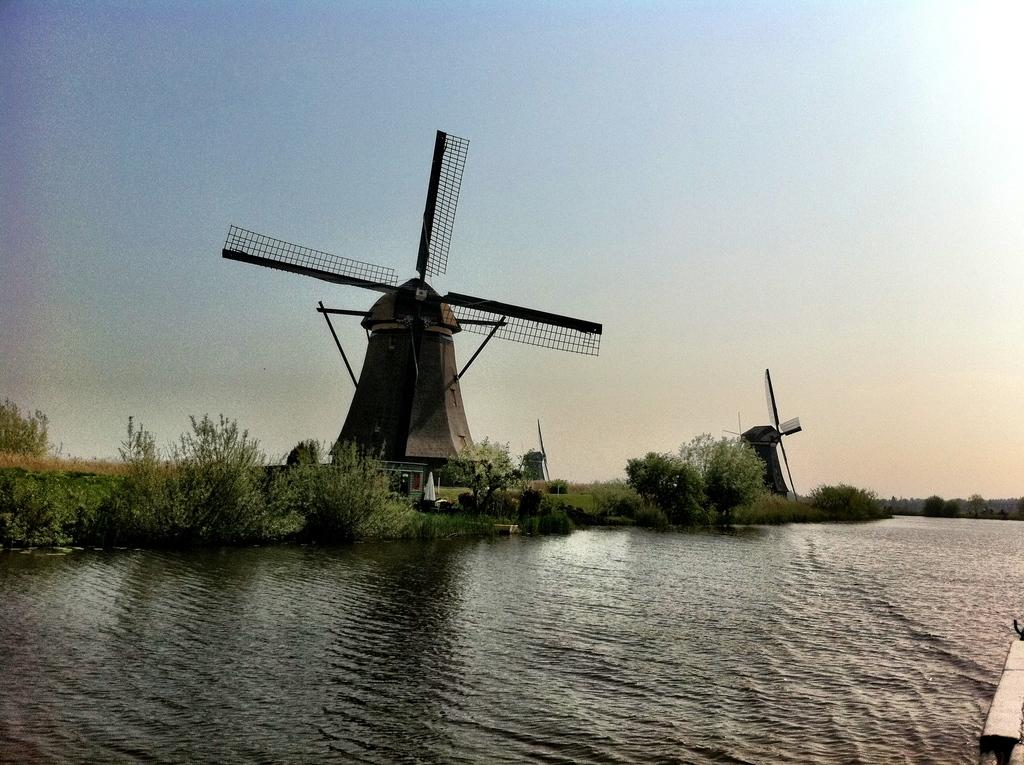What is located at the front of the image? There is water in the front of the image. What can be seen in the background of the image? There are windmills, plants, grass, sky, and objects visible in the background of the image. Can you describe the windmills in the background? The windmills are in the background of the image. What type of vegetation is present in the background of the image? There are plants and grass in the background of the image. What part of the natural environment is visible in the background of the image? The sky is visible in the background of the image. What type of ornament is hanging from the windmills in the image? There is no ornament hanging from the windmills in the image; they are simply windmills in the background. Can you describe the jail in the image? There is no jail present in the image. 